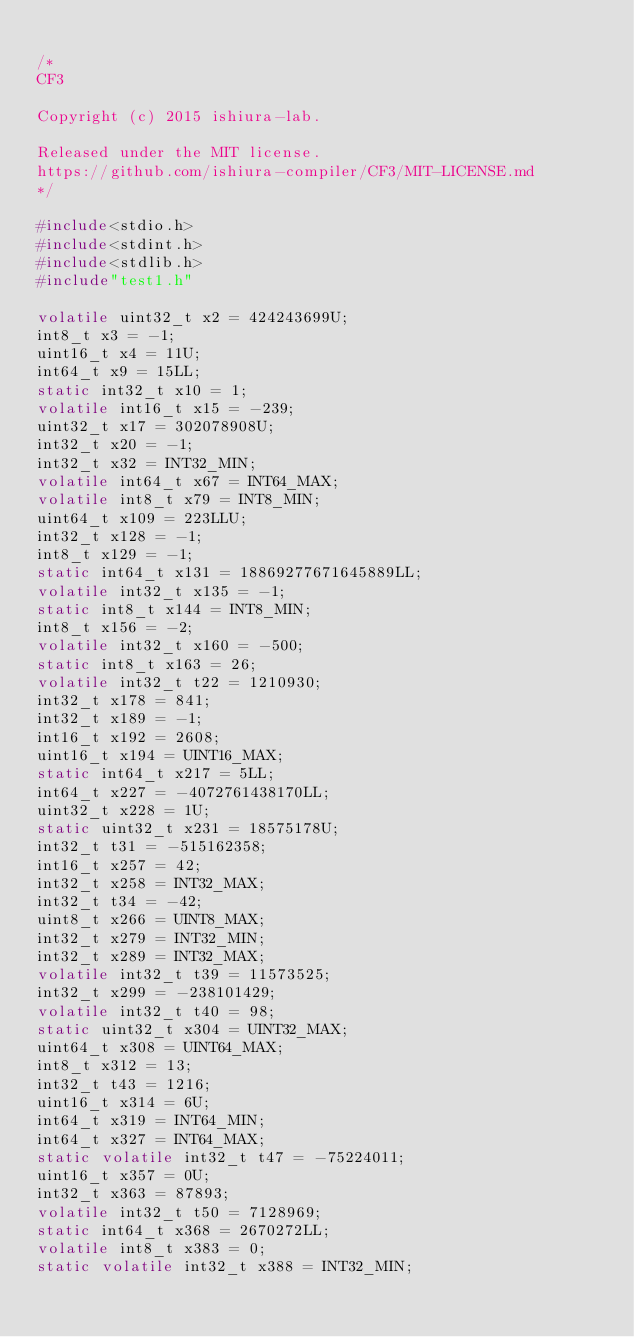Convert code to text. <code><loc_0><loc_0><loc_500><loc_500><_C_>
/*
CF3

Copyright (c) 2015 ishiura-lab.

Released under the MIT license.  
https://github.com/ishiura-compiler/CF3/MIT-LICENSE.md
*/

#include<stdio.h>
#include<stdint.h>
#include<stdlib.h>
#include"test1.h"

volatile uint32_t x2 = 424243699U;
int8_t x3 = -1;
uint16_t x4 = 11U;
int64_t x9 = 15LL;
static int32_t x10 = 1;
volatile int16_t x15 = -239;
uint32_t x17 = 302078908U;
int32_t x20 = -1;
int32_t x32 = INT32_MIN;
volatile int64_t x67 = INT64_MAX;
volatile int8_t x79 = INT8_MIN;
uint64_t x109 = 223LLU;
int32_t x128 = -1;
int8_t x129 = -1;
static int64_t x131 = 18869277671645889LL;
volatile int32_t x135 = -1;
static int8_t x144 = INT8_MIN;
int8_t x156 = -2;
volatile int32_t x160 = -500;
static int8_t x163 = 26;
volatile int32_t t22 = 1210930;
int32_t x178 = 841;
int32_t x189 = -1;
int16_t x192 = 2608;
uint16_t x194 = UINT16_MAX;
static int64_t x217 = 5LL;
int64_t x227 = -4072761438170LL;
uint32_t x228 = 1U;
static uint32_t x231 = 18575178U;
int32_t t31 = -515162358;
int16_t x257 = 42;
int32_t x258 = INT32_MAX;
int32_t t34 = -42;
uint8_t x266 = UINT8_MAX;
int32_t x279 = INT32_MIN;
int32_t x289 = INT32_MAX;
volatile int32_t t39 = 11573525;
int32_t x299 = -238101429;
volatile int32_t t40 = 98;
static uint32_t x304 = UINT32_MAX;
uint64_t x308 = UINT64_MAX;
int8_t x312 = 13;
int32_t t43 = 1216;
uint16_t x314 = 6U;
int64_t x319 = INT64_MIN;
int64_t x327 = INT64_MAX;
static volatile int32_t t47 = -75224011;
uint16_t x357 = 0U;
int32_t x363 = 87893;
volatile int32_t t50 = 7128969;
static int64_t x368 = 2670272LL;
volatile int8_t x383 = 0;
static volatile int32_t x388 = INT32_MIN;</code> 